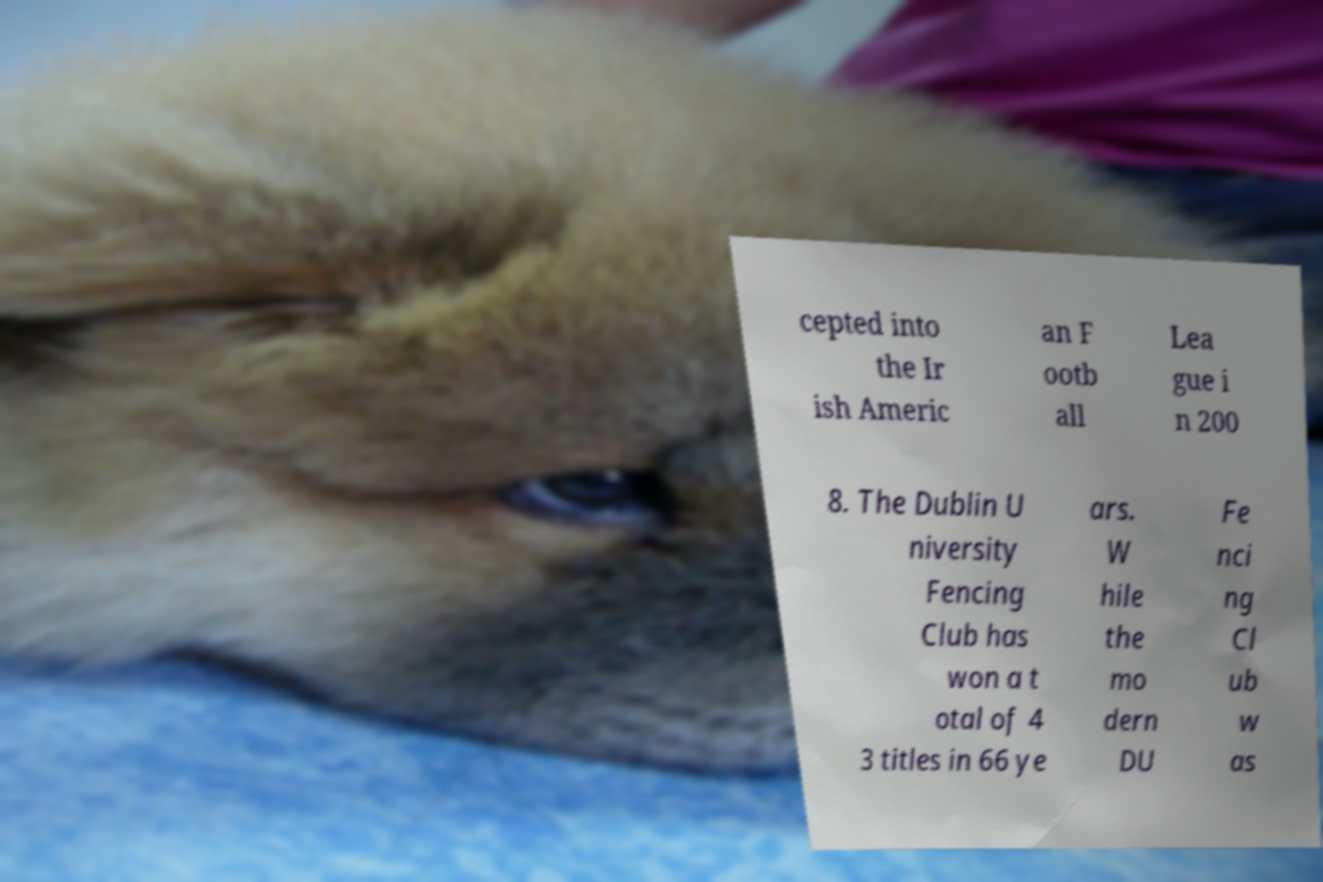For documentation purposes, I need the text within this image transcribed. Could you provide that? cepted into the Ir ish Americ an F ootb all Lea gue i n 200 8. The Dublin U niversity Fencing Club has won a t otal of 4 3 titles in 66 ye ars. W hile the mo dern DU Fe nci ng Cl ub w as 